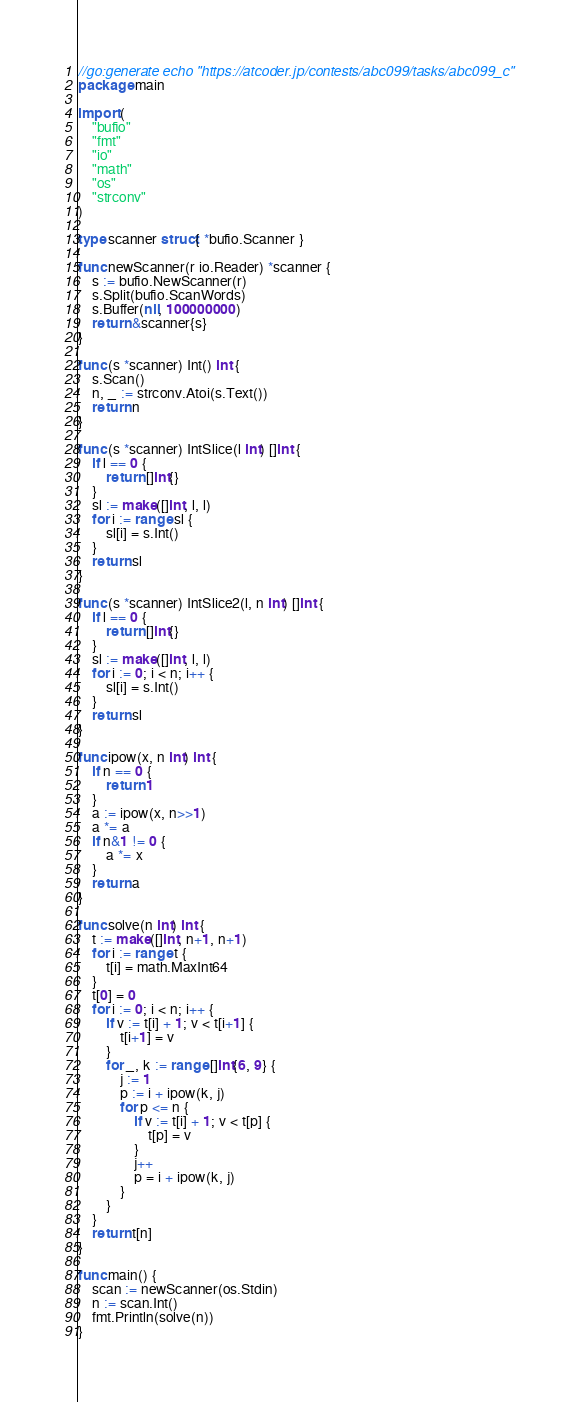<code> <loc_0><loc_0><loc_500><loc_500><_Go_>//go:generate echo "https://atcoder.jp/contests/abc099/tasks/abc099_c"
package main

import (
	"bufio"
	"fmt"
	"io"
	"math"
	"os"
	"strconv"
)

type scanner struct{ *bufio.Scanner }

func newScanner(r io.Reader) *scanner {
	s := bufio.NewScanner(r)
	s.Split(bufio.ScanWords)
	s.Buffer(nil, 100000000)
	return &scanner{s}
}

func (s *scanner) Int() int {
	s.Scan()
	n, _ := strconv.Atoi(s.Text())
	return n
}

func (s *scanner) IntSlice(l int) []int {
	if l == 0 {
		return []int{}
	}
	sl := make([]int, l, l)
	for i := range sl {
		sl[i] = s.Int()
	}
	return sl
}

func (s *scanner) IntSlice2(l, n int) []int {
	if l == 0 {
		return []int{}
	}
	sl := make([]int, l, l)
	for i := 0; i < n; i++ {
		sl[i] = s.Int()
	}
	return sl
}

func ipow(x, n int) int {
	if n == 0 {
		return 1
	}
	a := ipow(x, n>>1)
	a *= a
	if n&1 != 0 {
		a *= x
	}
	return a
}

func solve(n int) int {
	t := make([]int, n+1, n+1)
	for i := range t {
		t[i] = math.MaxInt64
	}
	t[0] = 0
	for i := 0; i < n; i++ {
		if v := t[i] + 1; v < t[i+1] {
			t[i+1] = v
		}
		for _, k := range []int{6, 9} {
			j := 1
			p := i + ipow(k, j)
			for p <= n {
				if v := t[i] + 1; v < t[p] {
					t[p] = v
				}
				j++
				p = i + ipow(k, j)
			}
		}
	}
	return t[n]
}

func main() {
	scan := newScanner(os.Stdin)
	n := scan.Int()
	fmt.Println(solve(n))
}
</code> 